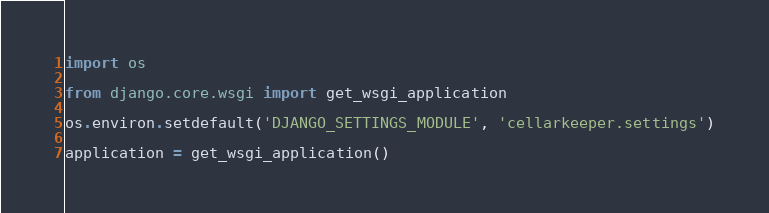<code> <loc_0><loc_0><loc_500><loc_500><_Python_>
import os

from django.core.wsgi import get_wsgi_application

os.environ.setdefault('DJANGO_SETTINGS_MODULE', 'cellarkeeper.settings')

application = get_wsgi_application()
</code> 